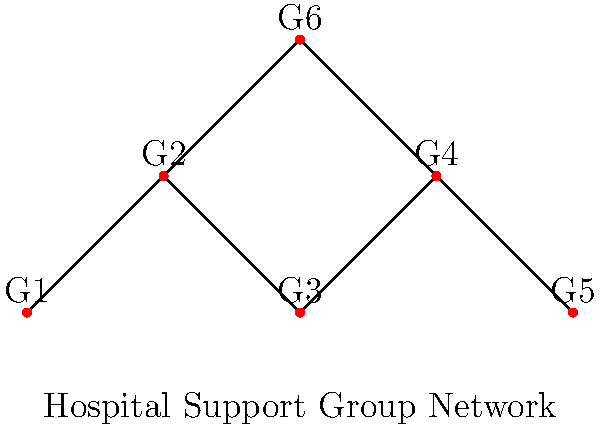In a hospital setting, six support groups (G1 to G6) for trauma patients are connected as shown in the graph. Each edge represents a shared resource or collaboration between groups. What is the minimum number of connections that need to be removed to completely isolate group G3 from all other groups? To solve this problem, we need to analyze the connectivity of group G3 (vertex 3 in the graph) to other groups:

1. Identify all connections to G3:
   - G3 is directly connected to G2 and G4
   - G3 is indirectly connected to G6 through G4

2. Count the minimum number of edges to remove:
   - Removing the edge between G2 and G3 cuts one connection
   - Removing the edge between G3 and G4 cuts the remaining connections (including the indirect one to G6)

3. Verify isolation:
   - After removing these two edges, G3 has no remaining connections to any other group

4. Consider alternative solutions:
   - There is no way to isolate G3 by removing fewer than 2 edges

Therefore, the minimum number of connections that need to be removed to completely isolate group G3 is 2.

This solution is relevant to the persona of a child psychiatrist specializing in trauma-related disorders, as it involves understanding the network of support groups in a hospital setting and how they are interconnected, which is crucial for managing patient care and resource allocation.
Answer: 2 connections 